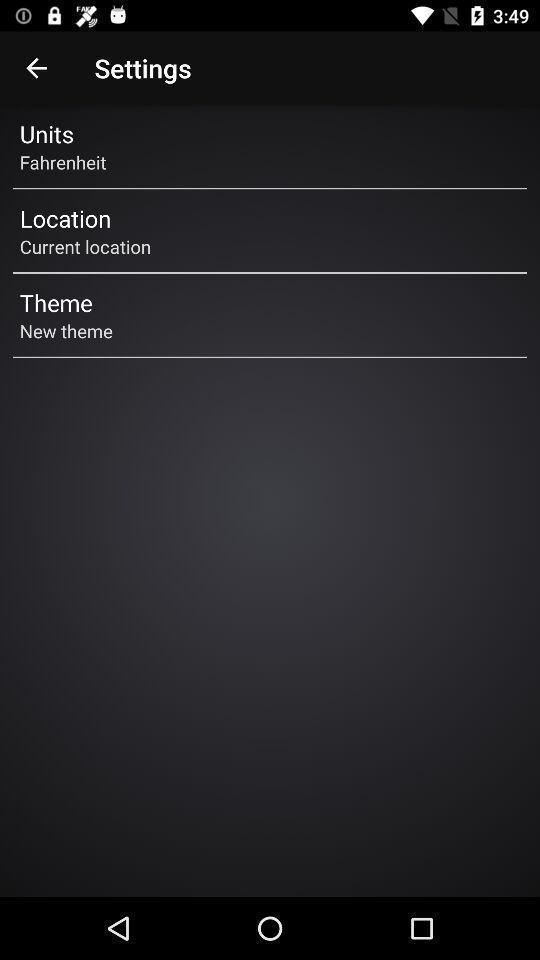What is the overall content of this screenshot? Settings page of a weather finding app is displaying. 